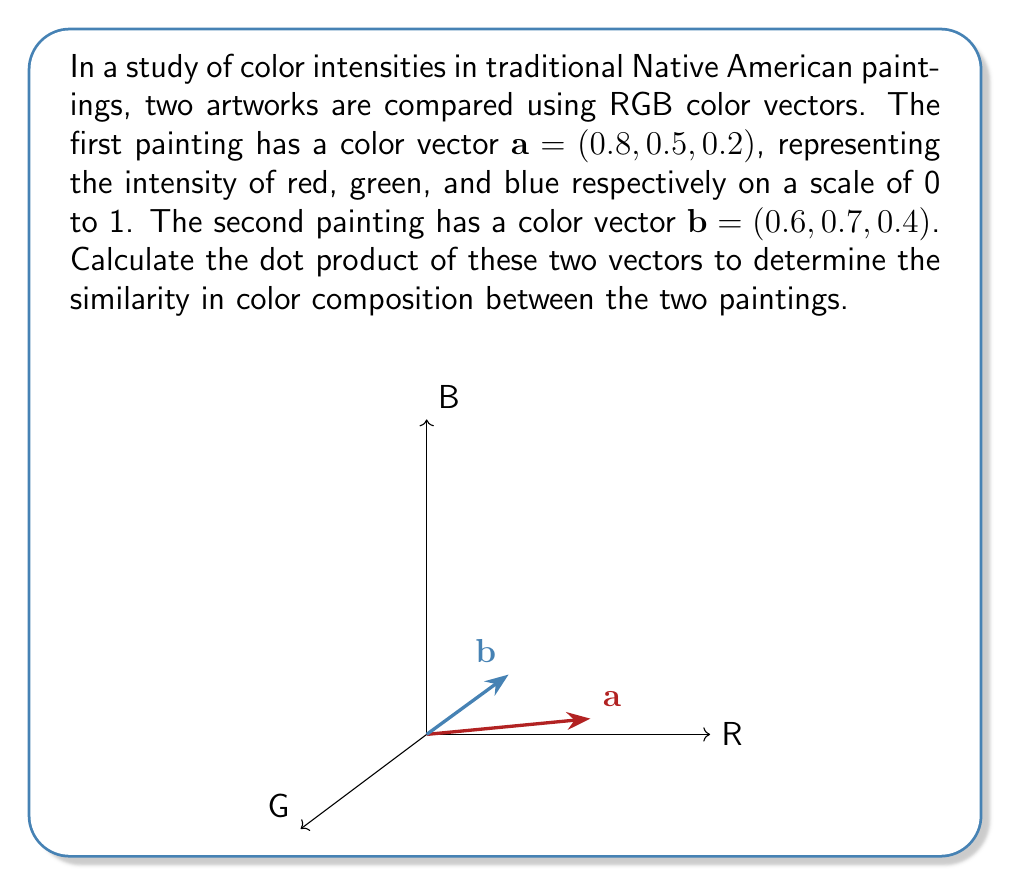Solve this math problem. To calculate the dot product of two vectors, we multiply corresponding components and sum the results. Let's follow these steps:

1) The dot product formula for two 3D vectors $\mathbf{a} = (a_1, a_2, a_3)$ and $\mathbf{b} = (b_1, b_2, b_3)$ is:

   $$\mathbf{a} \cdot \mathbf{b} = a_1b_1 + a_2b_2 + a_3b_3$$

2) In this case, we have:
   $\mathbf{a} = (0.8, 0.5, 0.2)$ and $\mathbf{b} = (0.6, 0.7, 0.4)$

3) Let's multiply the corresponding components:
   - Red: $0.8 \times 0.6 = 0.48$
   - Green: $0.5 \times 0.7 = 0.35$
   - Blue: $0.2 \times 0.4 = 0.08$

4) Now, sum these products:
   $$\mathbf{a} \cdot \mathbf{b} = 0.48 + 0.35 + 0.08 = 0.91$$

5) Therefore, the dot product of the two color vectors is 0.91.

This result indicates a relatively high similarity in color composition between the two paintings, as the dot product is closer to 1 (perfect similarity) than to 0 (no similarity).
Answer: $0.91$ 